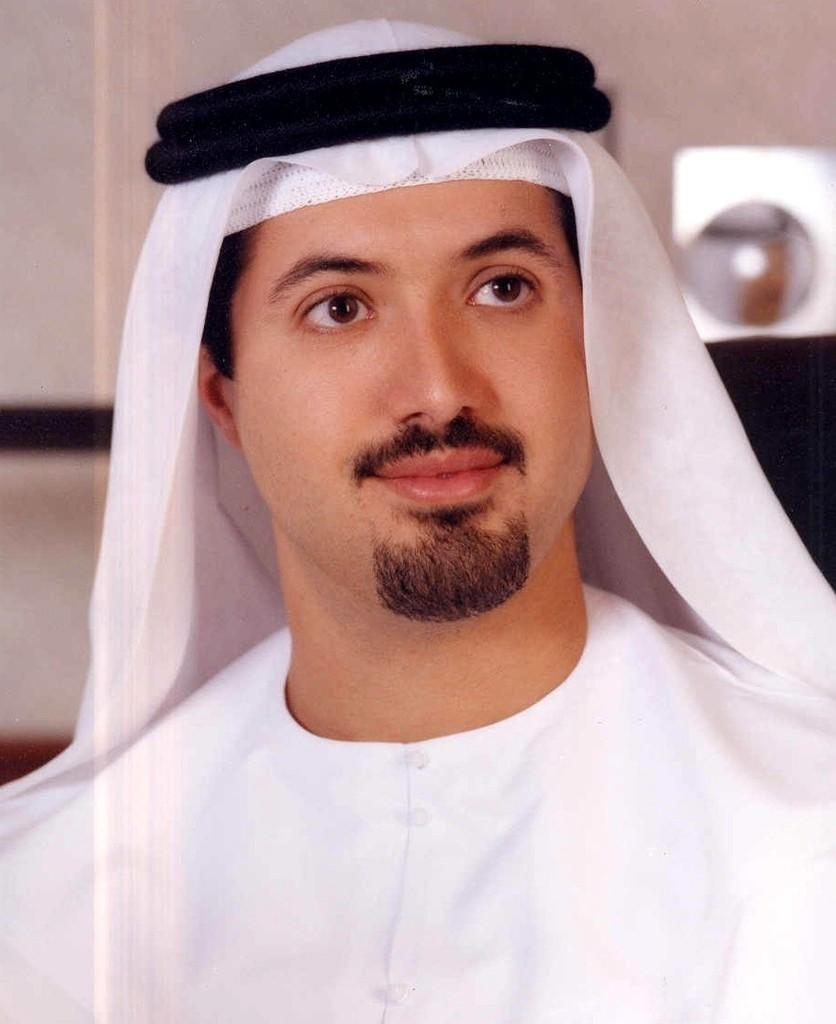Who or what is the main subject in the image? There is a person in the image. What is the person wearing on his head? The person is wearing a cloth on his head. What can be seen in the background of the image? There is a wall in the background of the image. What answer does the minister provide in the image? There is no minister present in the image, and therefore no answer can be provided. 